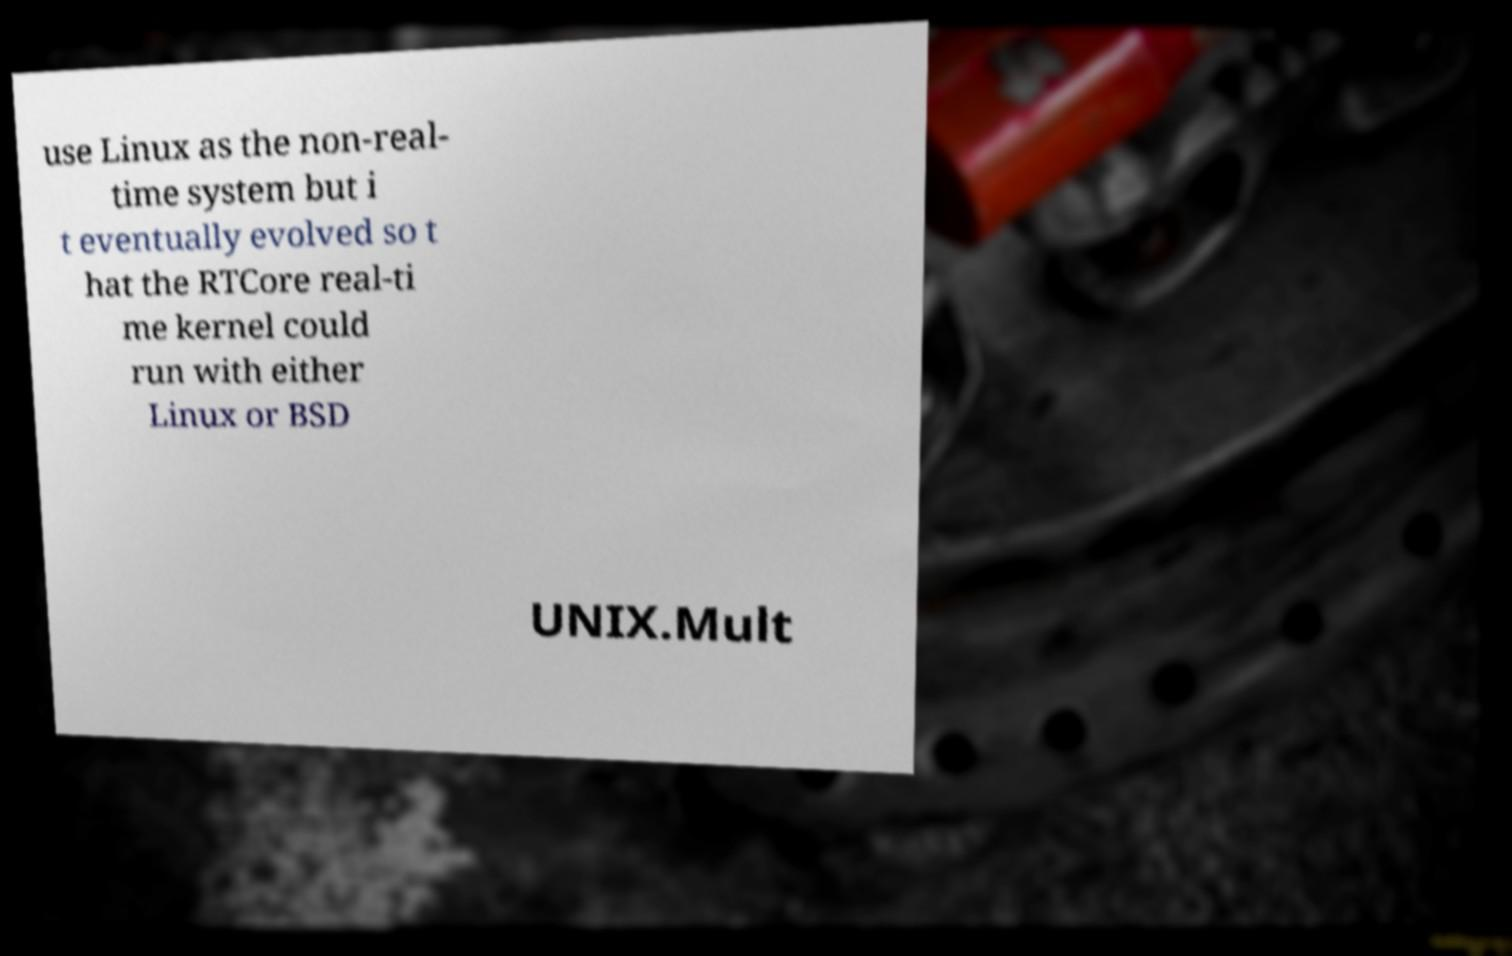Can you read and provide the text displayed in the image?This photo seems to have some interesting text. Can you extract and type it out for me? use Linux as the non-real- time system but i t eventually evolved so t hat the RTCore real-ti me kernel could run with either Linux or BSD UNIX.Mult 